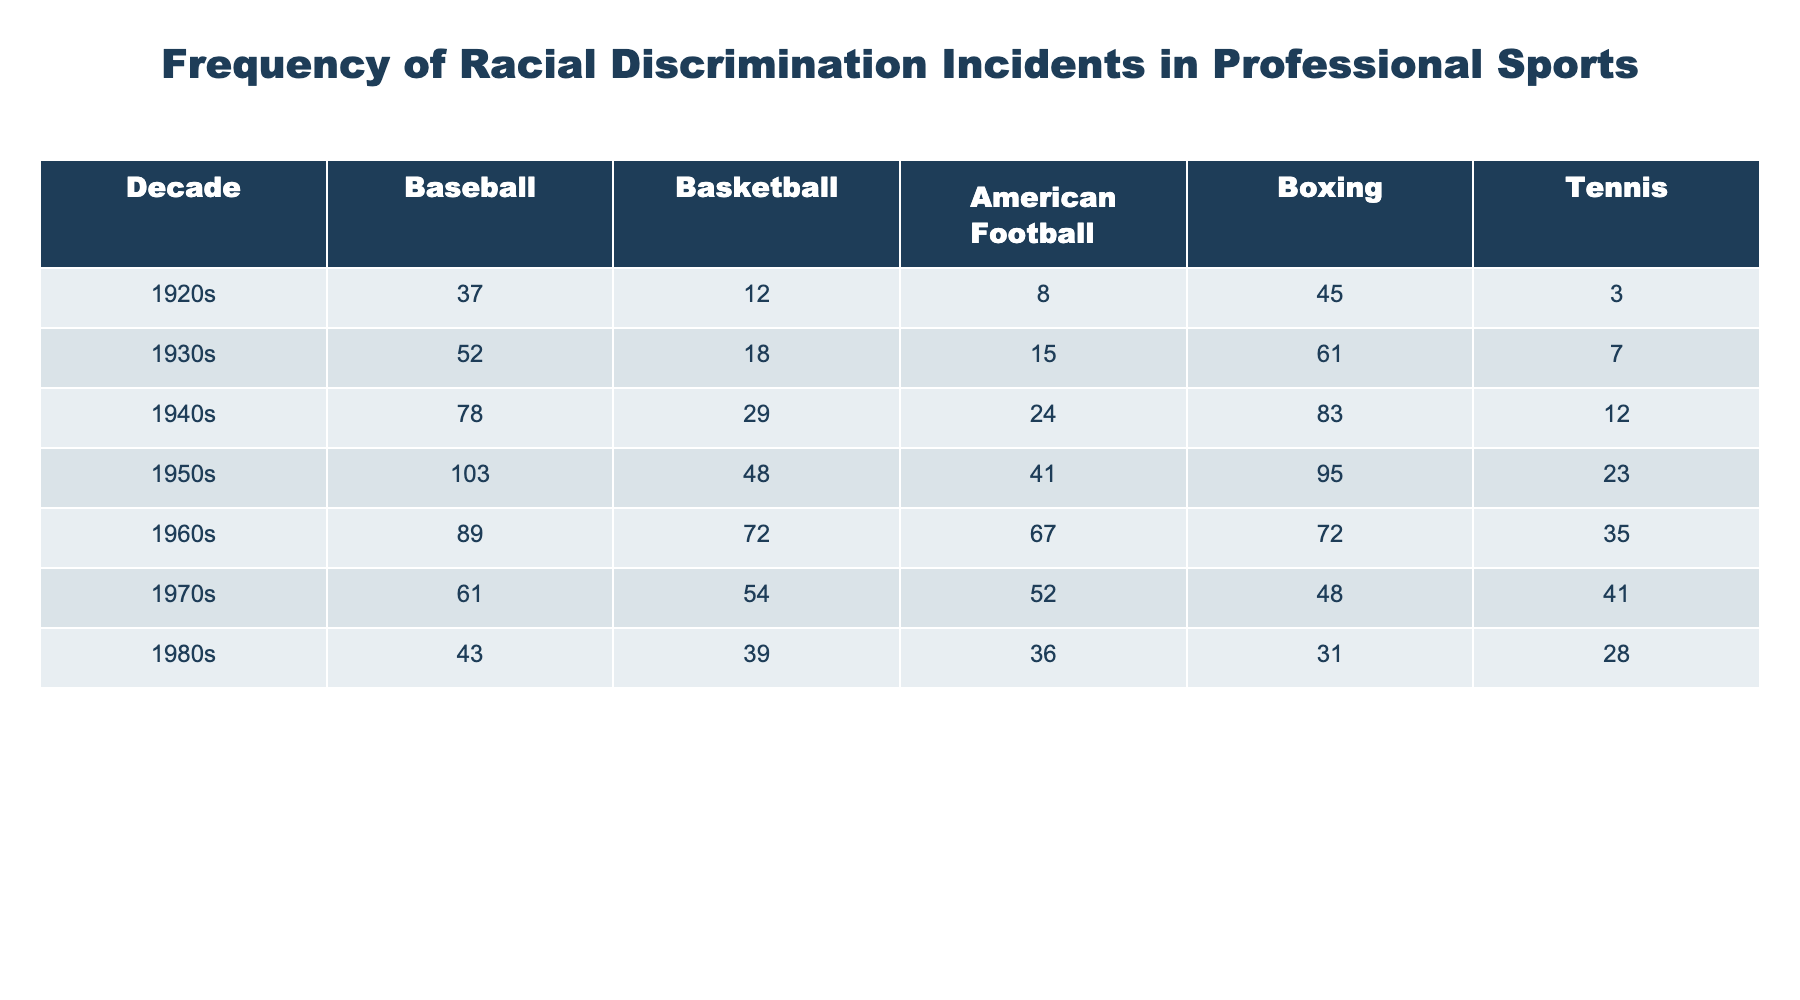What decade had the highest number of racial discrimination incidents in baseball? From the table, I can see that the 1950s had the highest number of incidents with a total of 103.
Answer: 1950s Which sport had the fewest incidents reported in the 1920s? Referring to the table, tennis reported the fewest incidents in the 1920s with only 3 cases.
Answer: Tennis In which decade did basketball incidents report a significant increase compared to the previous decade? Comparing the 1930s to the 1920s, basketball incidents increased from 12 to 18, which is a notable rise.
Answer: 1930s What was the total number of racial discrimination incidents reported in boxing during the 1940s? The table shows that there were 83 incidents reported in boxing during the 1940s.
Answer: 83 What sport had the highest total incidents reported over all decades? To find the sport with the highest total incidents, I need to add the total incidents for each sport across all decades. The totals for each sport are: Baseball (403), Basketball (239), American Football (243), Boxing (408), Tennis (174). Boxing had the highest total incidents overall.
Answer: Boxing What was the percentage decrease in racial discrimination incidents in baseball from the 1950s to the 1980s? The number of incidents in baseball decreased from 103 in the 1950s to 43 in the 1980s. The decrease is 103 - 43 = 60 incidents. The percentage decrease is (60/103) * 100 ≈ 58.25%.
Answer: Approximately 58.25% In the 1960s, how many more incidents were reported in basketball compared to tennis? According to the table, there were 72 incidents reported in basketball and 35 in tennis during the 1960s. The difference is 72 - 35 = 37 incidents.
Answer: 37 Is it true that the number of discrimination incidents in tennis was consistently increasing from the 1920s to the 1980s? Looking at the table, the incidents reported in tennis were 3 in the 1920s, then increased to 7 in the 1930s, but decreased to 12 in the 1940s and 23 in the 1950s, followed by subsequent decreases in the later decades. Therefore, the statement is false.
Answer: False What was the average number of incidents reported in American Football from the 1920s to the 1980s? I need to calculate the average of the incidents reported in American Football across the decades: (8 + 15 + 24 + 41 + 67 + 52 + 36) / 7 = 43. Therefore, the average is 43.
Answer: 43 Which decade saw a drop in reported incidents in both basketball and baseball? Referring to the table, the 1970s show a drop in incidents for both sports: basketball decreased from 72 in the 1960s to 54 in the 1970s, and baseball decreased from 89 to 61.
Answer: 1970s 